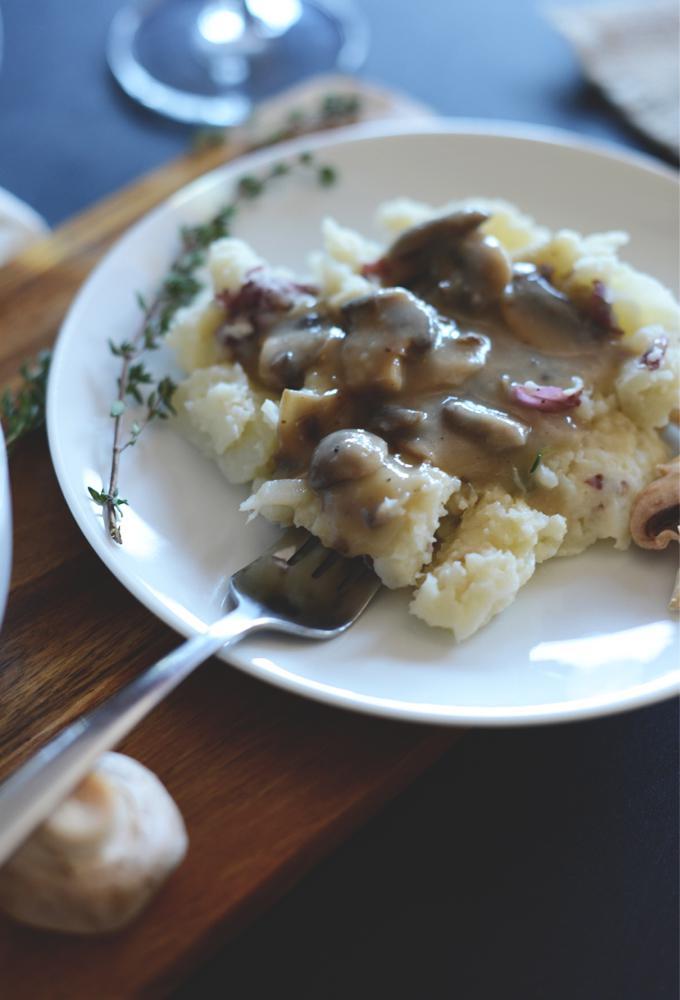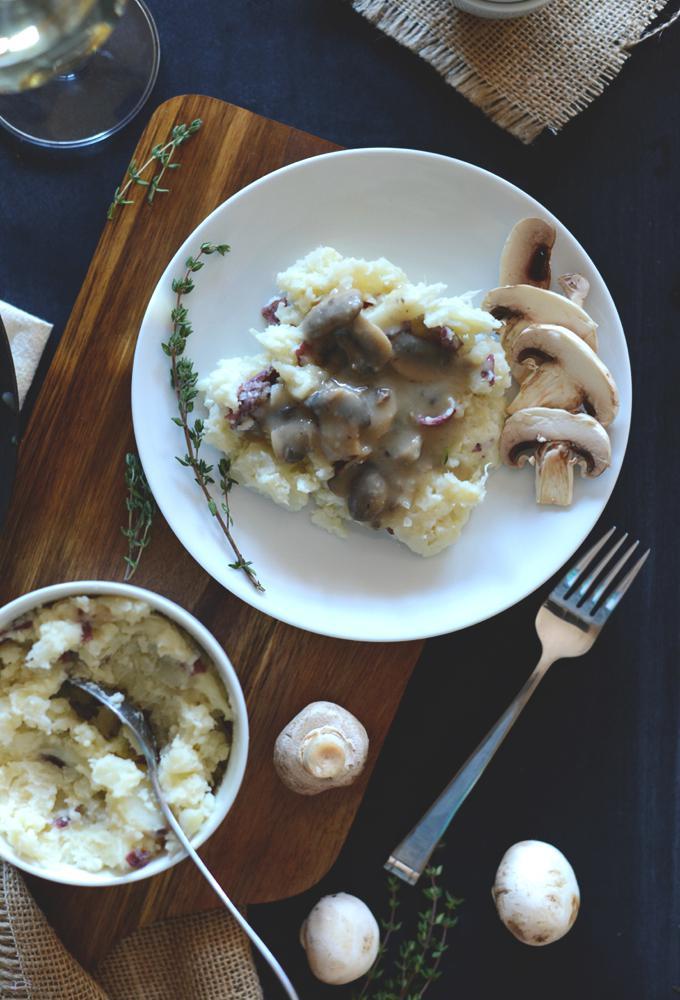The first image is the image on the left, the second image is the image on the right. For the images shown, is this caption "A silver fork is sitting near the food in the image on the right." true? Answer yes or no. Yes. The first image is the image on the left, the second image is the image on the right. For the images displayed, is the sentence "An image shows a fork resting on a white plate of food." factually correct? Answer yes or no. Yes. 